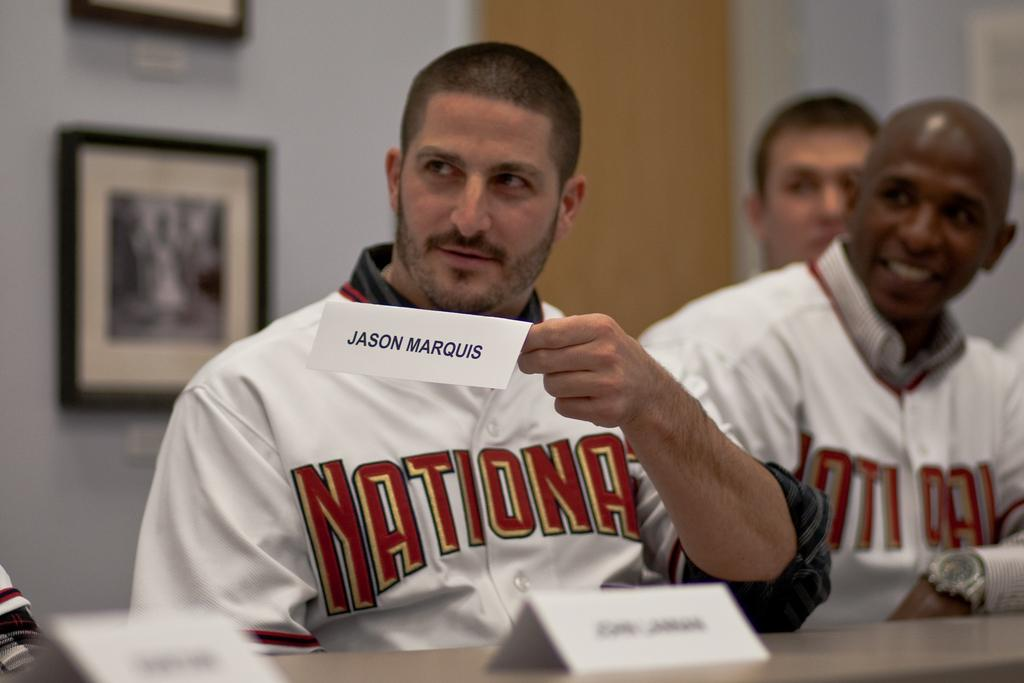<image>
Describe the image concisely. Jason Marquis holds up his paper name tag for someone to see. 